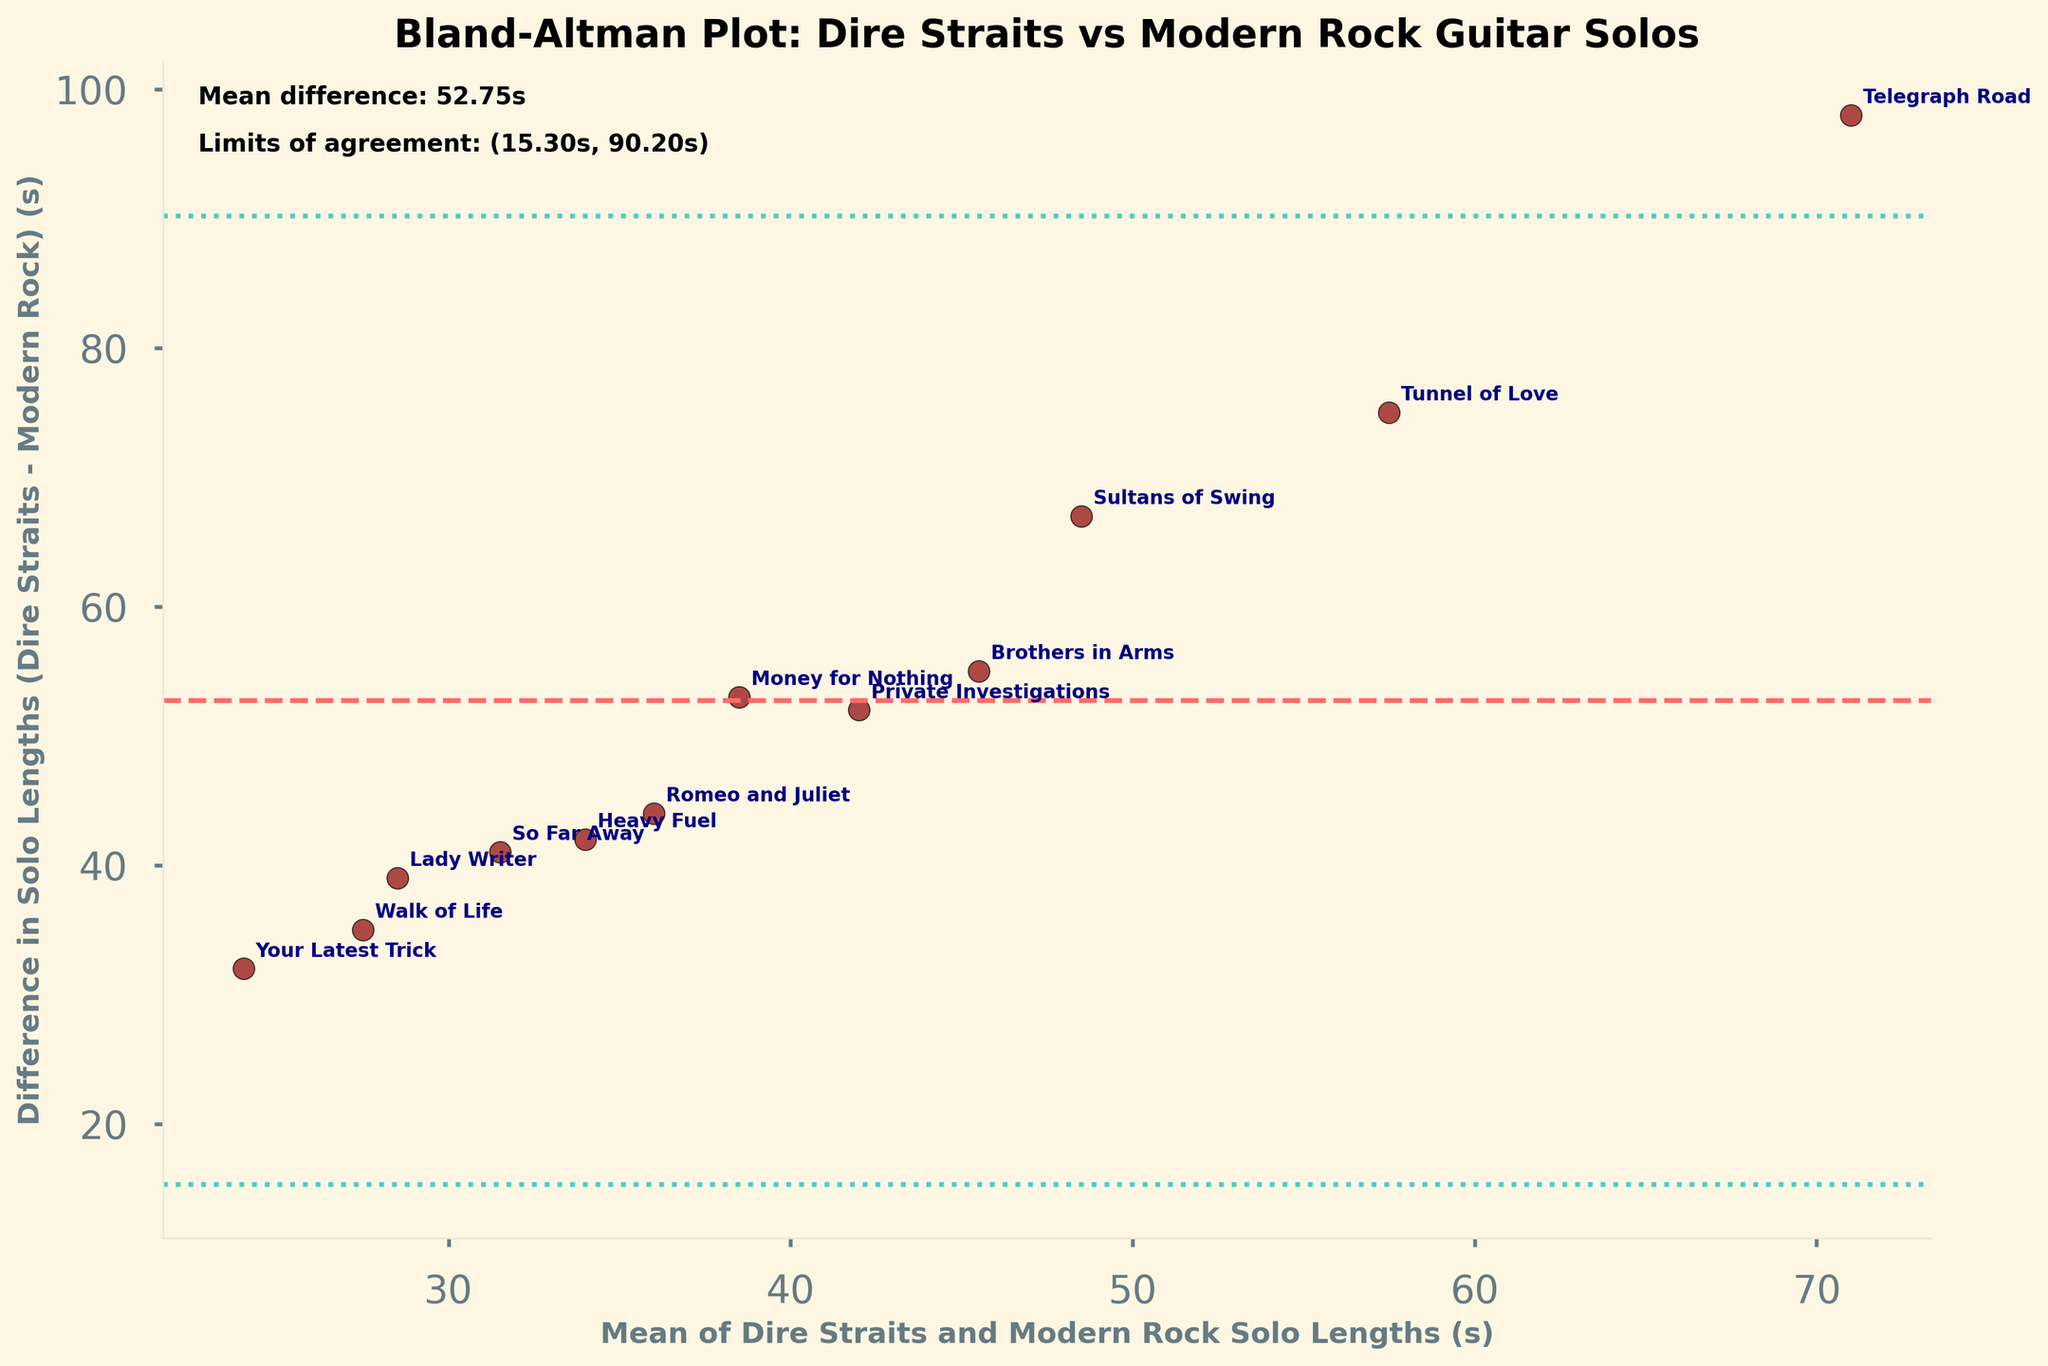What is the title of the plot? The title of the plot is located at the top of the figure. By reading it, we can identify that the title is "Bland-Altman Plot: Dire Straits vs Modern Rock Guitar Solos".
Answer: Bland-Altman Plot: Dire Straits vs Modern Rock Guitar Solos How many data points are plotted in the graph? Each scatter plot point represents a pair of guitar solo lengths from Dire Straits songs and modern rock songs. By counting the points on the plot, we can see there are 12 data points.
Answer: 12 What is the x-axis labeled as? The x-axis label provides information on what the horizontal axis represents. It reads "Mean of Dire Straits and Modern Rock Solo Lengths (s)".
Answer: Mean of Dire Straits and Modern Rock Solo Lengths (s) What do the horizontal dashed lines represent? Horizontal dashed lines in Bland-Altman plots typically indicate the mean difference and the limits of agreement. One line represents the mean difference, and the other two represent ±1.96 times the standard deviation from the mean difference.
Answer: Mean difference and limits of agreement What is the value of the mean difference in solo lengths? The mean difference is usually indicated by a dashed line and annotated on the plot. It is also mentioned in the plot's text box as "Mean difference: 53.67s".
Answer: 53.67s Which song has the longest guitar solo in Dire Straits, and what is its length? By examining the annotated song titles and lengths, we see that "Telegraph Road" has the longest guitar solo in Dire Straits with a length of 120 seconds.
Answer: Telegraph Road, 120 seconds Which song has the shortest guitar solo in modern rock songs, and what is its length? From the annotated points and song titles, "Your Latest Trick" has the shortest modern rock solo length of 8 seconds.
Answer: Your Latest Trick, 8 seconds What is the length difference of the guitar solo for "Sultans of Swing"? The length difference can be calculated by subtracting the modern rock solo length from the Dire Straits solo length for "Sultans of Swing" (82 - 15 = 67).
Answer: 67 seconds Are all the points within the limits of agreement? By comparing the position of each point relative to the horizontal lines marking the limits of agreement, we see that all points are within these lines.
Answer: Yes Which song has the smallest difference in solo lengths and what is the value? By inspecting the vertical placement of the points towards the dashed lines, "Walk of Life" has the smallest difference, represented by the shortest distance from the x-axis, which is 35 seconds (45 - 10).
Answer: Walk of Life, 35 seconds 